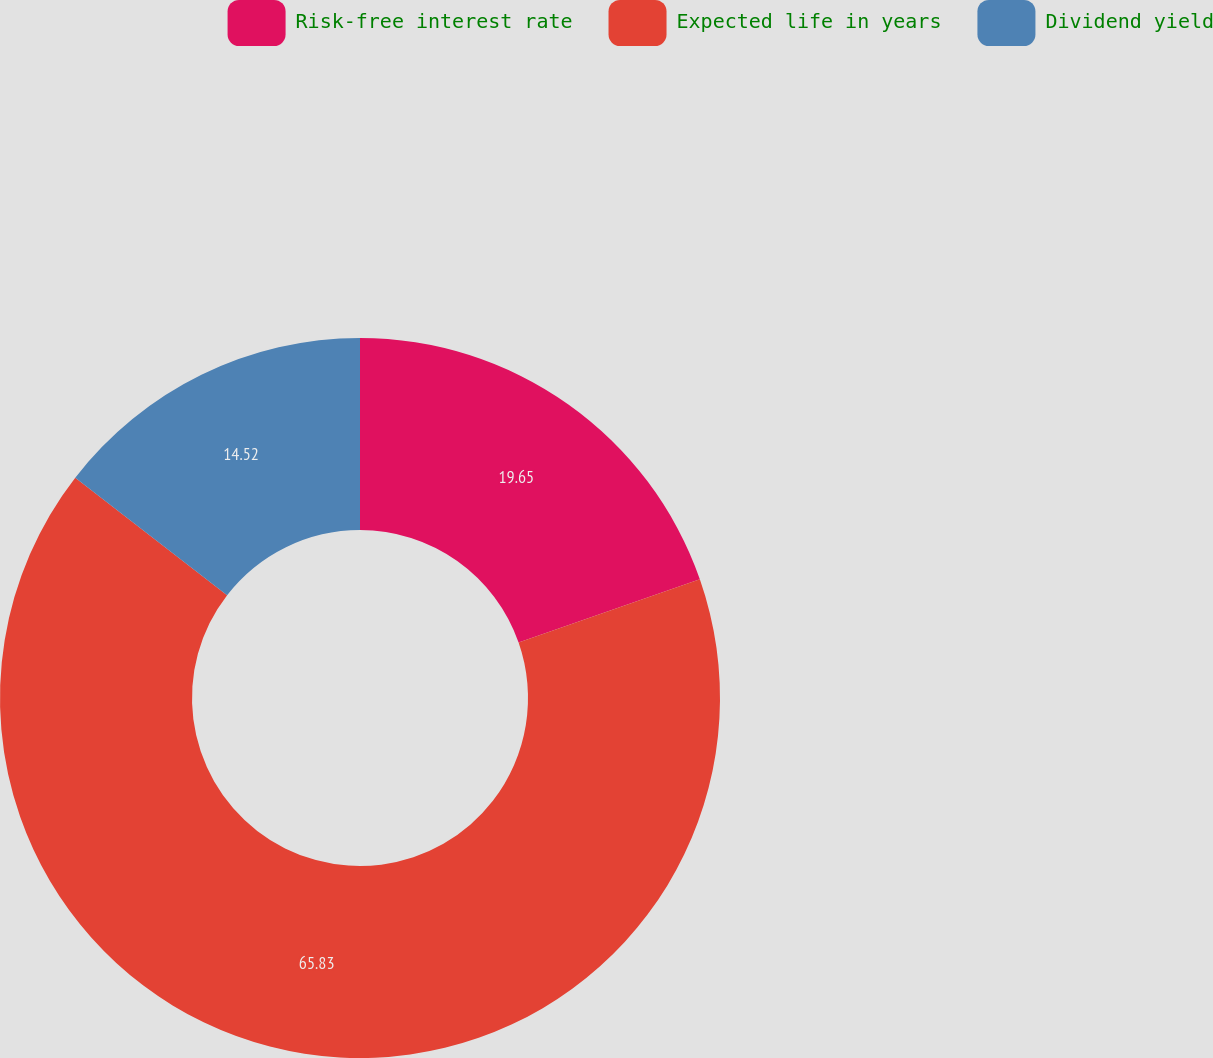Convert chart. <chart><loc_0><loc_0><loc_500><loc_500><pie_chart><fcel>Risk-free interest rate<fcel>Expected life in years<fcel>Dividend yield<nl><fcel>19.65%<fcel>65.83%<fcel>14.52%<nl></chart> 